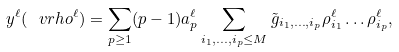Convert formula to latex. <formula><loc_0><loc_0><loc_500><loc_500>y ^ { \ell } ( \ v r h o ^ { \ell } ) = \sum _ { p \geq 1 } ( p - 1 ) a _ { p } ^ { \ell } \sum _ { i _ { 1 } , \dots , i _ { p } \leq M } \tilde { g } _ { i _ { 1 } , \dots , i _ { p } } \rho _ { i _ { 1 } } ^ { \ell } \dots \rho _ { i _ { p } } ^ { \ell } ,</formula> 